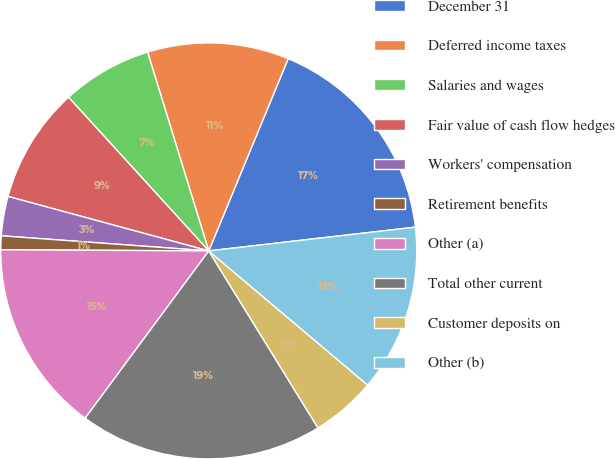Convert chart to OTSL. <chart><loc_0><loc_0><loc_500><loc_500><pie_chart><fcel>December 31<fcel>Deferred income taxes<fcel>Salaries and wages<fcel>Fair value of cash flow hedges<fcel>Workers' compensation<fcel>Retirement benefits<fcel>Other (a)<fcel>Total other current<fcel>Customer deposits on<fcel>Other (b)<nl><fcel>16.94%<fcel>10.99%<fcel>7.02%<fcel>9.01%<fcel>3.06%<fcel>1.07%<fcel>14.96%<fcel>18.93%<fcel>5.04%<fcel>12.98%<nl></chart> 